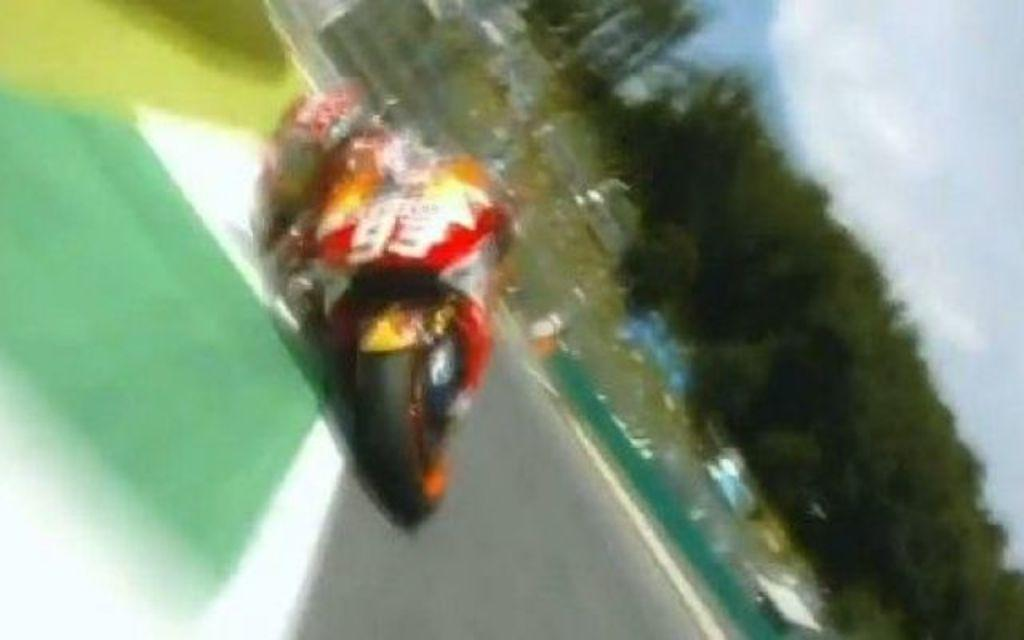What is the main subject of the image? The main subject of the image is a motorbike. Where is the motorbike located? The motorbike is on the road. What can be seen in the background of the image? There are trees and the sky visible in the background of the image. Where is the playground located in the image? There is no playground present in the image. What type of ball is being used by the person riding the motorbike? There is no ball or person riding the motorbike in the image. 